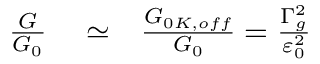<formula> <loc_0><loc_0><loc_500><loc_500>\begin{array} { r l r } { \frac { G } { G _ { 0 } } } & \simeq } & { \frac { G _ { 0 K , o f f } } { G _ { 0 } } = \frac { \Gamma _ { g } ^ { 2 } } { \varepsilon _ { 0 } ^ { 2 } } } \end{array}</formula> 